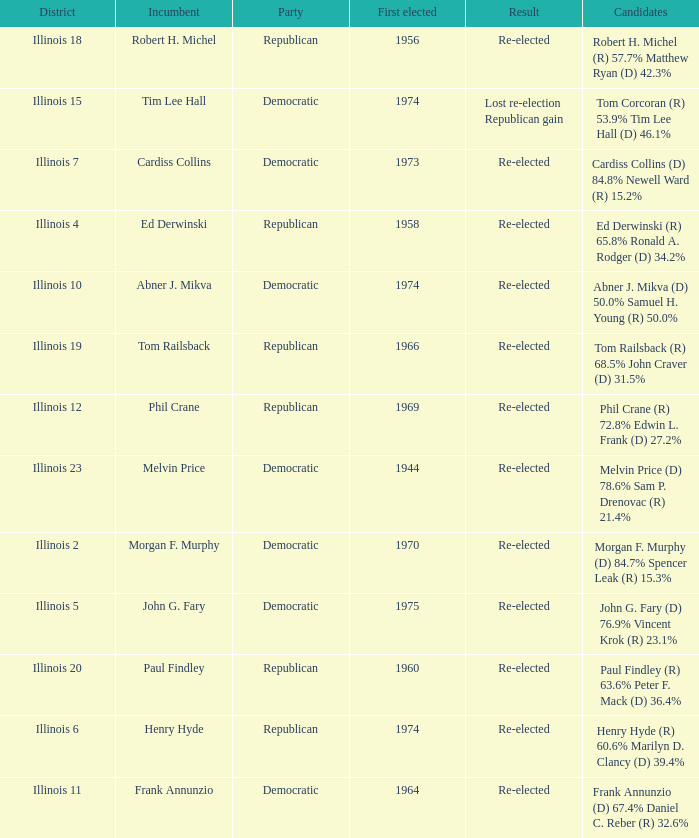Name the number of first elected for phil crane 1.0. 